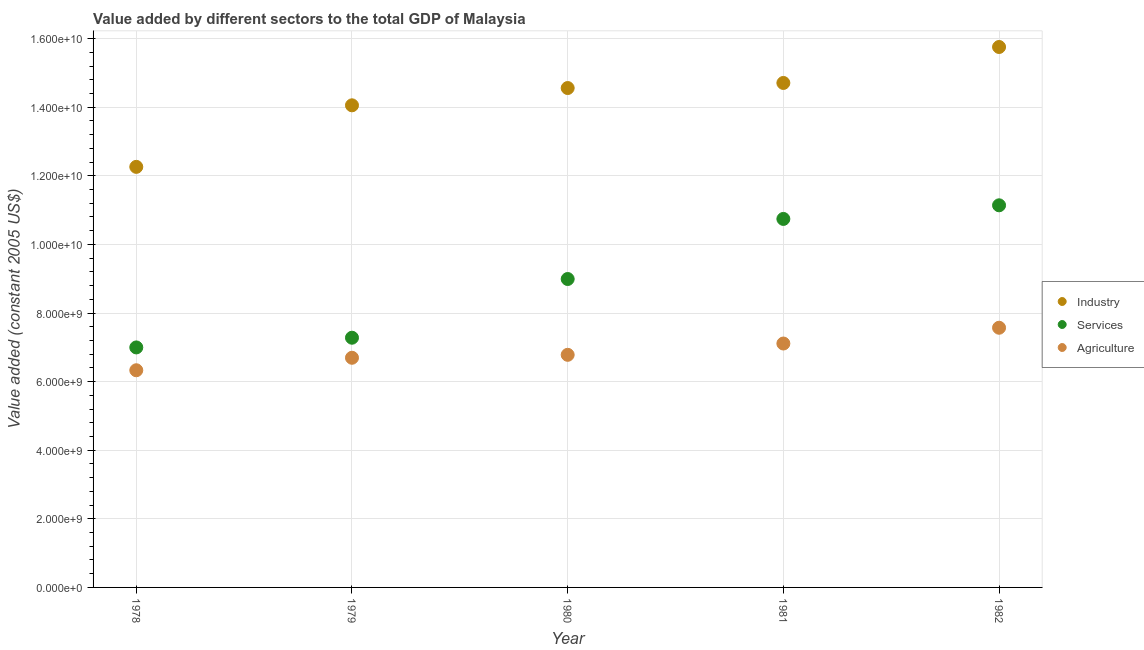Is the number of dotlines equal to the number of legend labels?
Keep it short and to the point. Yes. What is the value added by agricultural sector in 1980?
Your answer should be very brief. 6.78e+09. Across all years, what is the maximum value added by agricultural sector?
Offer a terse response. 7.57e+09. Across all years, what is the minimum value added by agricultural sector?
Offer a very short reply. 6.33e+09. In which year was the value added by agricultural sector minimum?
Make the answer very short. 1978. What is the total value added by industrial sector in the graph?
Ensure brevity in your answer.  7.13e+1. What is the difference between the value added by industrial sector in 1979 and that in 1981?
Your answer should be very brief. -6.52e+08. What is the difference between the value added by services in 1982 and the value added by industrial sector in 1981?
Provide a short and direct response. -3.57e+09. What is the average value added by services per year?
Provide a short and direct response. 9.03e+09. In the year 1979, what is the difference between the value added by agricultural sector and value added by services?
Give a very brief answer. -5.84e+08. What is the ratio of the value added by services in 1978 to that in 1982?
Make the answer very short. 0.63. Is the value added by services in 1979 less than that in 1982?
Offer a very short reply. Yes. What is the difference between the highest and the second highest value added by industrial sector?
Offer a very short reply. 1.05e+09. What is the difference between the highest and the lowest value added by agricultural sector?
Your answer should be compact. 1.24e+09. Is the sum of the value added by agricultural sector in 1978 and 1982 greater than the maximum value added by services across all years?
Offer a terse response. Yes. Is it the case that in every year, the sum of the value added by industrial sector and value added by services is greater than the value added by agricultural sector?
Your response must be concise. Yes. Does the value added by services monotonically increase over the years?
Your answer should be compact. Yes. Is the value added by industrial sector strictly greater than the value added by agricultural sector over the years?
Give a very brief answer. Yes. How many years are there in the graph?
Your answer should be compact. 5. Does the graph contain grids?
Provide a short and direct response. Yes. How are the legend labels stacked?
Your response must be concise. Vertical. What is the title of the graph?
Your response must be concise. Value added by different sectors to the total GDP of Malaysia. What is the label or title of the Y-axis?
Your answer should be very brief. Value added (constant 2005 US$). What is the Value added (constant 2005 US$) in Industry in 1978?
Offer a terse response. 1.23e+1. What is the Value added (constant 2005 US$) in Services in 1978?
Keep it short and to the point. 7.00e+09. What is the Value added (constant 2005 US$) of Agriculture in 1978?
Offer a very short reply. 6.33e+09. What is the Value added (constant 2005 US$) of Industry in 1979?
Your answer should be very brief. 1.41e+1. What is the Value added (constant 2005 US$) in Services in 1979?
Offer a terse response. 7.28e+09. What is the Value added (constant 2005 US$) in Agriculture in 1979?
Offer a very short reply. 6.70e+09. What is the Value added (constant 2005 US$) in Industry in 1980?
Provide a short and direct response. 1.46e+1. What is the Value added (constant 2005 US$) of Services in 1980?
Keep it short and to the point. 8.99e+09. What is the Value added (constant 2005 US$) of Agriculture in 1980?
Your answer should be compact. 6.78e+09. What is the Value added (constant 2005 US$) of Industry in 1981?
Ensure brevity in your answer.  1.47e+1. What is the Value added (constant 2005 US$) in Services in 1981?
Give a very brief answer. 1.07e+1. What is the Value added (constant 2005 US$) of Agriculture in 1981?
Offer a terse response. 7.11e+09. What is the Value added (constant 2005 US$) in Industry in 1982?
Your answer should be compact. 1.58e+1. What is the Value added (constant 2005 US$) in Services in 1982?
Your answer should be very brief. 1.11e+1. What is the Value added (constant 2005 US$) of Agriculture in 1982?
Keep it short and to the point. 7.57e+09. Across all years, what is the maximum Value added (constant 2005 US$) in Industry?
Keep it short and to the point. 1.58e+1. Across all years, what is the maximum Value added (constant 2005 US$) of Services?
Provide a succinct answer. 1.11e+1. Across all years, what is the maximum Value added (constant 2005 US$) of Agriculture?
Offer a terse response. 7.57e+09. Across all years, what is the minimum Value added (constant 2005 US$) in Industry?
Keep it short and to the point. 1.23e+1. Across all years, what is the minimum Value added (constant 2005 US$) of Services?
Offer a terse response. 7.00e+09. Across all years, what is the minimum Value added (constant 2005 US$) in Agriculture?
Give a very brief answer. 6.33e+09. What is the total Value added (constant 2005 US$) of Industry in the graph?
Offer a very short reply. 7.13e+1. What is the total Value added (constant 2005 US$) in Services in the graph?
Ensure brevity in your answer.  4.52e+1. What is the total Value added (constant 2005 US$) of Agriculture in the graph?
Provide a succinct answer. 3.45e+1. What is the difference between the Value added (constant 2005 US$) of Industry in 1978 and that in 1979?
Provide a succinct answer. -1.79e+09. What is the difference between the Value added (constant 2005 US$) in Services in 1978 and that in 1979?
Offer a terse response. -2.83e+08. What is the difference between the Value added (constant 2005 US$) of Agriculture in 1978 and that in 1979?
Ensure brevity in your answer.  -3.64e+08. What is the difference between the Value added (constant 2005 US$) of Industry in 1978 and that in 1980?
Provide a short and direct response. -2.30e+09. What is the difference between the Value added (constant 2005 US$) in Services in 1978 and that in 1980?
Your response must be concise. -1.99e+09. What is the difference between the Value added (constant 2005 US$) in Agriculture in 1978 and that in 1980?
Ensure brevity in your answer.  -4.50e+08. What is the difference between the Value added (constant 2005 US$) in Industry in 1978 and that in 1981?
Make the answer very short. -2.45e+09. What is the difference between the Value added (constant 2005 US$) of Services in 1978 and that in 1981?
Your answer should be very brief. -3.75e+09. What is the difference between the Value added (constant 2005 US$) of Agriculture in 1978 and that in 1981?
Give a very brief answer. -7.79e+08. What is the difference between the Value added (constant 2005 US$) of Industry in 1978 and that in 1982?
Your answer should be compact. -3.49e+09. What is the difference between the Value added (constant 2005 US$) in Services in 1978 and that in 1982?
Provide a succinct answer. -4.14e+09. What is the difference between the Value added (constant 2005 US$) in Agriculture in 1978 and that in 1982?
Offer a terse response. -1.24e+09. What is the difference between the Value added (constant 2005 US$) of Industry in 1979 and that in 1980?
Provide a succinct answer. -5.04e+08. What is the difference between the Value added (constant 2005 US$) of Services in 1979 and that in 1980?
Make the answer very short. -1.71e+09. What is the difference between the Value added (constant 2005 US$) in Agriculture in 1979 and that in 1980?
Your response must be concise. -8.59e+07. What is the difference between the Value added (constant 2005 US$) of Industry in 1979 and that in 1981?
Provide a succinct answer. -6.52e+08. What is the difference between the Value added (constant 2005 US$) in Services in 1979 and that in 1981?
Offer a very short reply. -3.46e+09. What is the difference between the Value added (constant 2005 US$) of Agriculture in 1979 and that in 1981?
Ensure brevity in your answer.  -4.15e+08. What is the difference between the Value added (constant 2005 US$) of Industry in 1979 and that in 1982?
Give a very brief answer. -1.70e+09. What is the difference between the Value added (constant 2005 US$) of Services in 1979 and that in 1982?
Give a very brief answer. -3.86e+09. What is the difference between the Value added (constant 2005 US$) of Agriculture in 1979 and that in 1982?
Ensure brevity in your answer.  -8.75e+08. What is the difference between the Value added (constant 2005 US$) of Industry in 1980 and that in 1981?
Offer a very short reply. -1.48e+08. What is the difference between the Value added (constant 2005 US$) of Services in 1980 and that in 1981?
Offer a very short reply. -1.75e+09. What is the difference between the Value added (constant 2005 US$) in Agriculture in 1980 and that in 1981?
Your answer should be compact. -3.29e+08. What is the difference between the Value added (constant 2005 US$) of Industry in 1980 and that in 1982?
Offer a very short reply. -1.20e+09. What is the difference between the Value added (constant 2005 US$) of Services in 1980 and that in 1982?
Offer a very short reply. -2.15e+09. What is the difference between the Value added (constant 2005 US$) in Agriculture in 1980 and that in 1982?
Ensure brevity in your answer.  -7.89e+08. What is the difference between the Value added (constant 2005 US$) of Industry in 1981 and that in 1982?
Provide a short and direct response. -1.05e+09. What is the difference between the Value added (constant 2005 US$) in Services in 1981 and that in 1982?
Ensure brevity in your answer.  -3.97e+08. What is the difference between the Value added (constant 2005 US$) of Agriculture in 1981 and that in 1982?
Your answer should be very brief. -4.60e+08. What is the difference between the Value added (constant 2005 US$) in Industry in 1978 and the Value added (constant 2005 US$) in Services in 1979?
Ensure brevity in your answer.  4.98e+09. What is the difference between the Value added (constant 2005 US$) in Industry in 1978 and the Value added (constant 2005 US$) in Agriculture in 1979?
Your answer should be very brief. 5.57e+09. What is the difference between the Value added (constant 2005 US$) of Services in 1978 and the Value added (constant 2005 US$) of Agriculture in 1979?
Make the answer very short. 3.01e+08. What is the difference between the Value added (constant 2005 US$) of Industry in 1978 and the Value added (constant 2005 US$) of Services in 1980?
Provide a short and direct response. 3.27e+09. What is the difference between the Value added (constant 2005 US$) of Industry in 1978 and the Value added (constant 2005 US$) of Agriculture in 1980?
Your response must be concise. 5.48e+09. What is the difference between the Value added (constant 2005 US$) of Services in 1978 and the Value added (constant 2005 US$) of Agriculture in 1980?
Ensure brevity in your answer.  2.16e+08. What is the difference between the Value added (constant 2005 US$) in Industry in 1978 and the Value added (constant 2005 US$) in Services in 1981?
Provide a succinct answer. 1.52e+09. What is the difference between the Value added (constant 2005 US$) in Industry in 1978 and the Value added (constant 2005 US$) in Agriculture in 1981?
Keep it short and to the point. 5.15e+09. What is the difference between the Value added (constant 2005 US$) in Services in 1978 and the Value added (constant 2005 US$) in Agriculture in 1981?
Ensure brevity in your answer.  -1.14e+08. What is the difference between the Value added (constant 2005 US$) of Industry in 1978 and the Value added (constant 2005 US$) of Services in 1982?
Keep it short and to the point. 1.12e+09. What is the difference between the Value added (constant 2005 US$) of Industry in 1978 and the Value added (constant 2005 US$) of Agriculture in 1982?
Your response must be concise. 4.69e+09. What is the difference between the Value added (constant 2005 US$) of Services in 1978 and the Value added (constant 2005 US$) of Agriculture in 1982?
Offer a very short reply. -5.74e+08. What is the difference between the Value added (constant 2005 US$) of Industry in 1979 and the Value added (constant 2005 US$) of Services in 1980?
Provide a short and direct response. 5.06e+09. What is the difference between the Value added (constant 2005 US$) in Industry in 1979 and the Value added (constant 2005 US$) in Agriculture in 1980?
Provide a succinct answer. 7.27e+09. What is the difference between the Value added (constant 2005 US$) of Services in 1979 and the Value added (constant 2005 US$) of Agriculture in 1980?
Your response must be concise. 4.98e+08. What is the difference between the Value added (constant 2005 US$) in Industry in 1979 and the Value added (constant 2005 US$) in Services in 1981?
Offer a terse response. 3.31e+09. What is the difference between the Value added (constant 2005 US$) of Industry in 1979 and the Value added (constant 2005 US$) of Agriculture in 1981?
Provide a succinct answer. 6.94e+09. What is the difference between the Value added (constant 2005 US$) of Services in 1979 and the Value added (constant 2005 US$) of Agriculture in 1981?
Your response must be concise. 1.69e+08. What is the difference between the Value added (constant 2005 US$) in Industry in 1979 and the Value added (constant 2005 US$) in Services in 1982?
Your answer should be very brief. 2.92e+09. What is the difference between the Value added (constant 2005 US$) in Industry in 1979 and the Value added (constant 2005 US$) in Agriculture in 1982?
Provide a short and direct response. 6.48e+09. What is the difference between the Value added (constant 2005 US$) of Services in 1979 and the Value added (constant 2005 US$) of Agriculture in 1982?
Offer a terse response. -2.91e+08. What is the difference between the Value added (constant 2005 US$) of Industry in 1980 and the Value added (constant 2005 US$) of Services in 1981?
Your answer should be compact. 3.82e+09. What is the difference between the Value added (constant 2005 US$) of Industry in 1980 and the Value added (constant 2005 US$) of Agriculture in 1981?
Make the answer very short. 7.45e+09. What is the difference between the Value added (constant 2005 US$) in Services in 1980 and the Value added (constant 2005 US$) in Agriculture in 1981?
Keep it short and to the point. 1.88e+09. What is the difference between the Value added (constant 2005 US$) in Industry in 1980 and the Value added (constant 2005 US$) in Services in 1982?
Provide a short and direct response. 3.42e+09. What is the difference between the Value added (constant 2005 US$) in Industry in 1980 and the Value added (constant 2005 US$) in Agriculture in 1982?
Your response must be concise. 6.99e+09. What is the difference between the Value added (constant 2005 US$) in Services in 1980 and the Value added (constant 2005 US$) in Agriculture in 1982?
Keep it short and to the point. 1.42e+09. What is the difference between the Value added (constant 2005 US$) in Industry in 1981 and the Value added (constant 2005 US$) in Services in 1982?
Offer a very short reply. 3.57e+09. What is the difference between the Value added (constant 2005 US$) in Industry in 1981 and the Value added (constant 2005 US$) in Agriculture in 1982?
Your answer should be compact. 7.14e+09. What is the difference between the Value added (constant 2005 US$) in Services in 1981 and the Value added (constant 2005 US$) in Agriculture in 1982?
Provide a succinct answer. 3.17e+09. What is the average Value added (constant 2005 US$) of Industry per year?
Give a very brief answer. 1.43e+1. What is the average Value added (constant 2005 US$) in Services per year?
Give a very brief answer. 9.03e+09. What is the average Value added (constant 2005 US$) of Agriculture per year?
Your response must be concise. 6.90e+09. In the year 1978, what is the difference between the Value added (constant 2005 US$) of Industry and Value added (constant 2005 US$) of Services?
Offer a very short reply. 5.26e+09. In the year 1978, what is the difference between the Value added (constant 2005 US$) of Industry and Value added (constant 2005 US$) of Agriculture?
Your answer should be compact. 5.93e+09. In the year 1978, what is the difference between the Value added (constant 2005 US$) in Services and Value added (constant 2005 US$) in Agriculture?
Offer a terse response. 6.65e+08. In the year 1979, what is the difference between the Value added (constant 2005 US$) of Industry and Value added (constant 2005 US$) of Services?
Ensure brevity in your answer.  6.78e+09. In the year 1979, what is the difference between the Value added (constant 2005 US$) in Industry and Value added (constant 2005 US$) in Agriculture?
Offer a terse response. 7.36e+09. In the year 1979, what is the difference between the Value added (constant 2005 US$) of Services and Value added (constant 2005 US$) of Agriculture?
Your answer should be compact. 5.84e+08. In the year 1980, what is the difference between the Value added (constant 2005 US$) in Industry and Value added (constant 2005 US$) in Services?
Keep it short and to the point. 5.57e+09. In the year 1980, what is the difference between the Value added (constant 2005 US$) in Industry and Value added (constant 2005 US$) in Agriculture?
Give a very brief answer. 7.78e+09. In the year 1980, what is the difference between the Value added (constant 2005 US$) in Services and Value added (constant 2005 US$) in Agriculture?
Your answer should be very brief. 2.21e+09. In the year 1981, what is the difference between the Value added (constant 2005 US$) in Industry and Value added (constant 2005 US$) in Services?
Keep it short and to the point. 3.96e+09. In the year 1981, what is the difference between the Value added (constant 2005 US$) of Industry and Value added (constant 2005 US$) of Agriculture?
Your answer should be very brief. 7.60e+09. In the year 1981, what is the difference between the Value added (constant 2005 US$) of Services and Value added (constant 2005 US$) of Agriculture?
Your answer should be compact. 3.63e+09. In the year 1982, what is the difference between the Value added (constant 2005 US$) of Industry and Value added (constant 2005 US$) of Services?
Ensure brevity in your answer.  4.62e+09. In the year 1982, what is the difference between the Value added (constant 2005 US$) in Industry and Value added (constant 2005 US$) in Agriculture?
Your answer should be compact. 8.19e+09. In the year 1982, what is the difference between the Value added (constant 2005 US$) of Services and Value added (constant 2005 US$) of Agriculture?
Give a very brief answer. 3.57e+09. What is the ratio of the Value added (constant 2005 US$) in Industry in 1978 to that in 1979?
Give a very brief answer. 0.87. What is the ratio of the Value added (constant 2005 US$) in Services in 1978 to that in 1979?
Offer a terse response. 0.96. What is the ratio of the Value added (constant 2005 US$) in Agriculture in 1978 to that in 1979?
Offer a very short reply. 0.95. What is the ratio of the Value added (constant 2005 US$) of Industry in 1978 to that in 1980?
Give a very brief answer. 0.84. What is the ratio of the Value added (constant 2005 US$) in Services in 1978 to that in 1980?
Make the answer very short. 0.78. What is the ratio of the Value added (constant 2005 US$) of Agriculture in 1978 to that in 1980?
Ensure brevity in your answer.  0.93. What is the ratio of the Value added (constant 2005 US$) in Industry in 1978 to that in 1981?
Your response must be concise. 0.83. What is the ratio of the Value added (constant 2005 US$) of Services in 1978 to that in 1981?
Offer a terse response. 0.65. What is the ratio of the Value added (constant 2005 US$) of Agriculture in 1978 to that in 1981?
Make the answer very short. 0.89. What is the ratio of the Value added (constant 2005 US$) in Industry in 1978 to that in 1982?
Your response must be concise. 0.78. What is the ratio of the Value added (constant 2005 US$) in Services in 1978 to that in 1982?
Provide a short and direct response. 0.63. What is the ratio of the Value added (constant 2005 US$) of Agriculture in 1978 to that in 1982?
Offer a terse response. 0.84. What is the ratio of the Value added (constant 2005 US$) of Industry in 1979 to that in 1980?
Offer a very short reply. 0.97. What is the ratio of the Value added (constant 2005 US$) of Services in 1979 to that in 1980?
Provide a succinct answer. 0.81. What is the ratio of the Value added (constant 2005 US$) of Agriculture in 1979 to that in 1980?
Ensure brevity in your answer.  0.99. What is the ratio of the Value added (constant 2005 US$) of Industry in 1979 to that in 1981?
Your answer should be compact. 0.96. What is the ratio of the Value added (constant 2005 US$) in Services in 1979 to that in 1981?
Ensure brevity in your answer.  0.68. What is the ratio of the Value added (constant 2005 US$) of Agriculture in 1979 to that in 1981?
Your response must be concise. 0.94. What is the ratio of the Value added (constant 2005 US$) in Industry in 1979 to that in 1982?
Ensure brevity in your answer.  0.89. What is the ratio of the Value added (constant 2005 US$) of Services in 1979 to that in 1982?
Your response must be concise. 0.65. What is the ratio of the Value added (constant 2005 US$) in Agriculture in 1979 to that in 1982?
Provide a succinct answer. 0.88. What is the ratio of the Value added (constant 2005 US$) of Industry in 1980 to that in 1981?
Provide a short and direct response. 0.99. What is the ratio of the Value added (constant 2005 US$) of Services in 1980 to that in 1981?
Your answer should be compact. 0.84. What is the ratio of the Value added (constant 2005 US$) of Agriculture in 1980 to that in 1981?
Give a very brief answer. 0.95. What is the ratio of the Value added (constant 2005 US$) of Industry in 1980 to that in 1982?
Your answer should be compact. 0.92. What is the ratio of the Value added (constant 2005 US$) in Services in 1980 to that in 1982?
Provide a short and direct response. 0.81. What is the ratio of the Value added (constant 2005 US$) of Agriculture in 1980 to that in 1982?
Your response must be concise. 0.9. What is the ratio of the Value added (constant 2005 US$) in Industry in 1981 to that in 1982?
Offer a very short reply. 0.93. What is the ratio of the Value added (constant 2005 US$) of Services in 1981 to that in 1982?
Your answer should be compact. 0.96. What is the ratio of the Value added (constant 2005 US$) in Agriculture in 1981 to that in 1982?
Ensure brevity in your answer.  0.94. What is the difference between the highest and the second highest Value added (constant 2005 US$) of Industry?
Provide a succinct answer. 1.05e+09. What is the difference between the highest and the second highest Value added (constant 2005 US$) in Services?
Make the answer very short. 3.97e+08. What is the difference between the highest and the second highest Value added (constant 2005 US$) in Agriculture?
Offer a terse response. 4.60e+08. What is the difference between the highest and the lowest Value added (constant 2005 US$) in Industry?
Provide a succinct answer. 3.49e+09. What is the difference between the highest and the lowest Value added (constant 2005 US$) in Services?
Keep it short and to the point. 4.14e+09. What is the difference between the highest and the lowest Value added (constant 2005 US$) in Agriculture?
Give a very brief answer. 1.24e+09. 